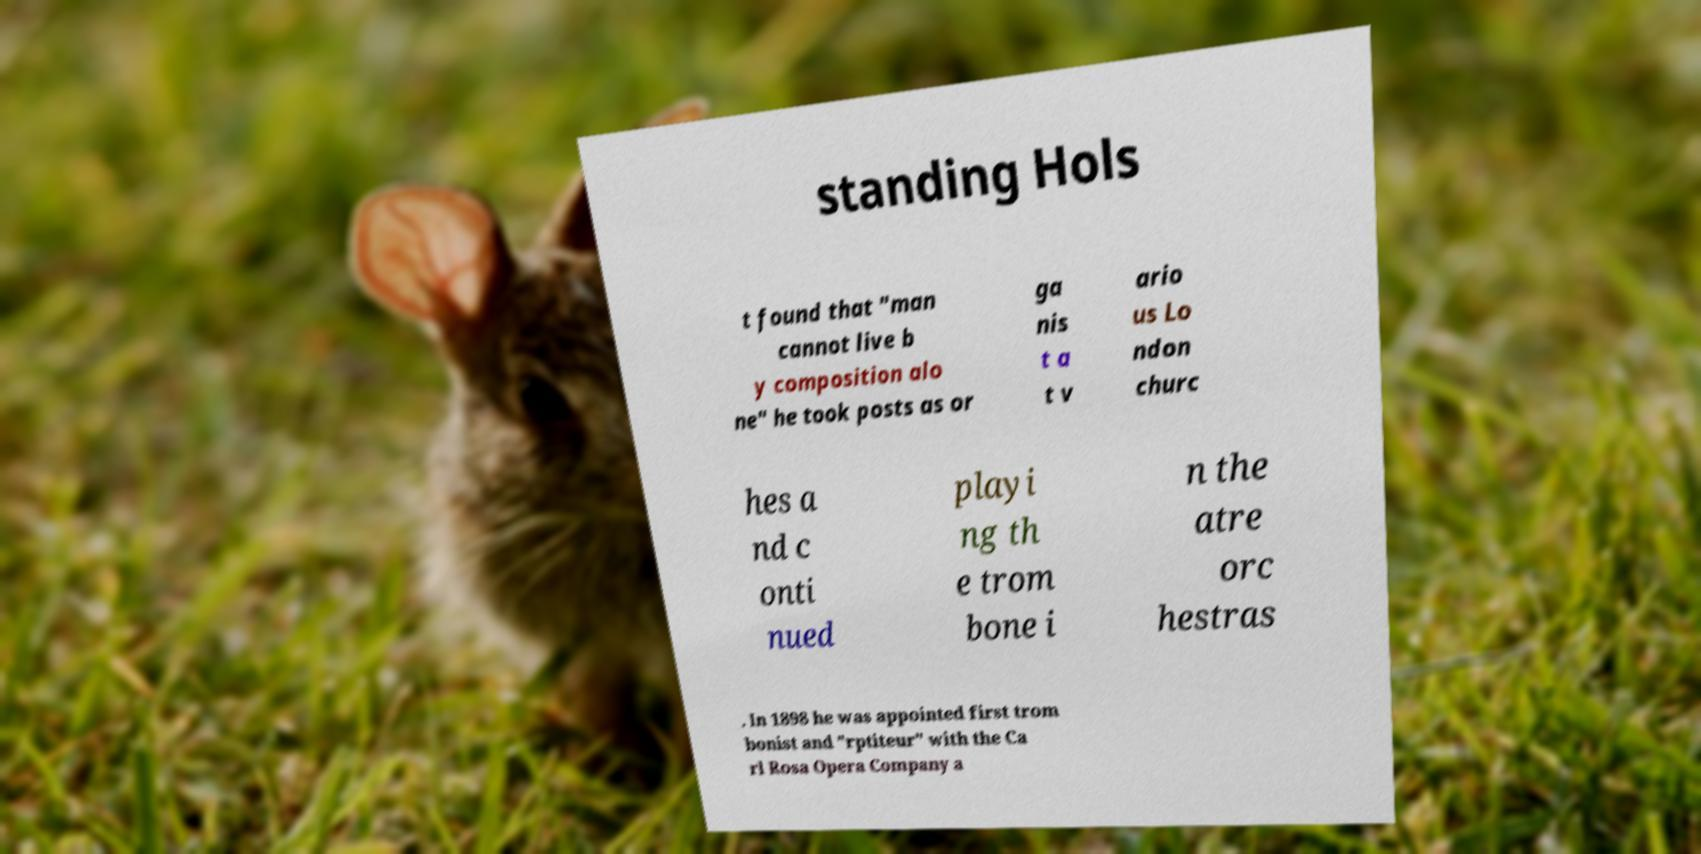For documentation purposes, I need the text within this image transcribed. Could you provide that? standing Hols t found that "man cannot live b y composition alo ne" he took posts as or ga nis t a t v ario us Lo ndon churc hes a nd c onti nued playi ng th e trom bone i n the atre orc hestras . In 1898 he was appointed first trom bonist and "rptiteur" with the Ca rl Rosa Opera Company a 